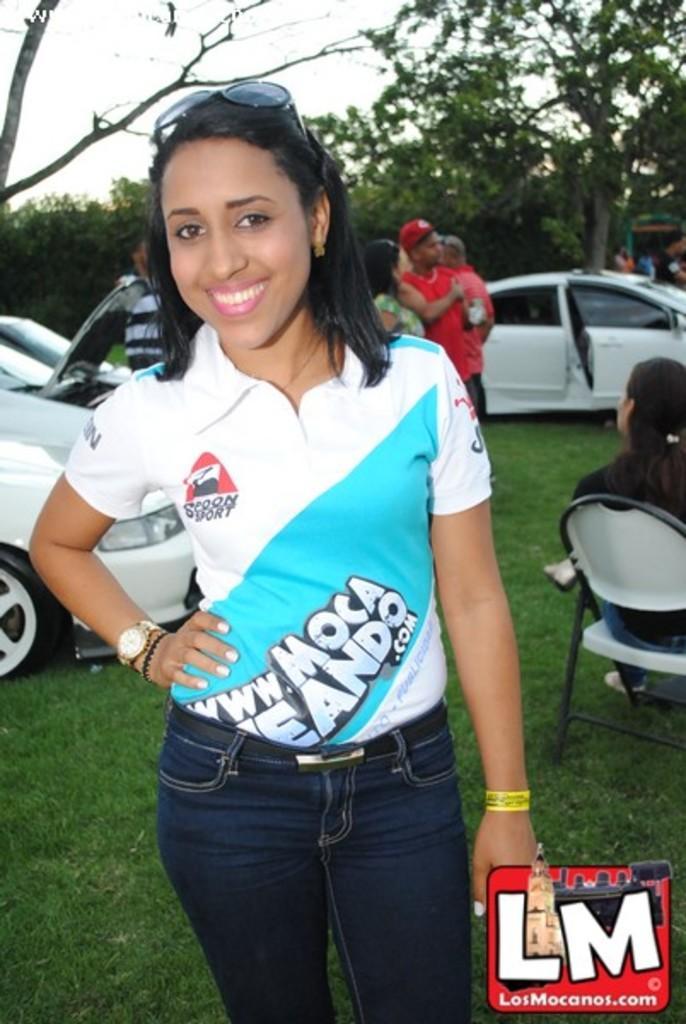Could you give a brief overview of what you see in this image? At the top we can see sky. These are trees. Here we can see persons standing and sitting on a chair. This is a grass. These are cars in white colour. Here we can see a woman standing in front portion of a picture and she is carrying a pretty smile on her face. 